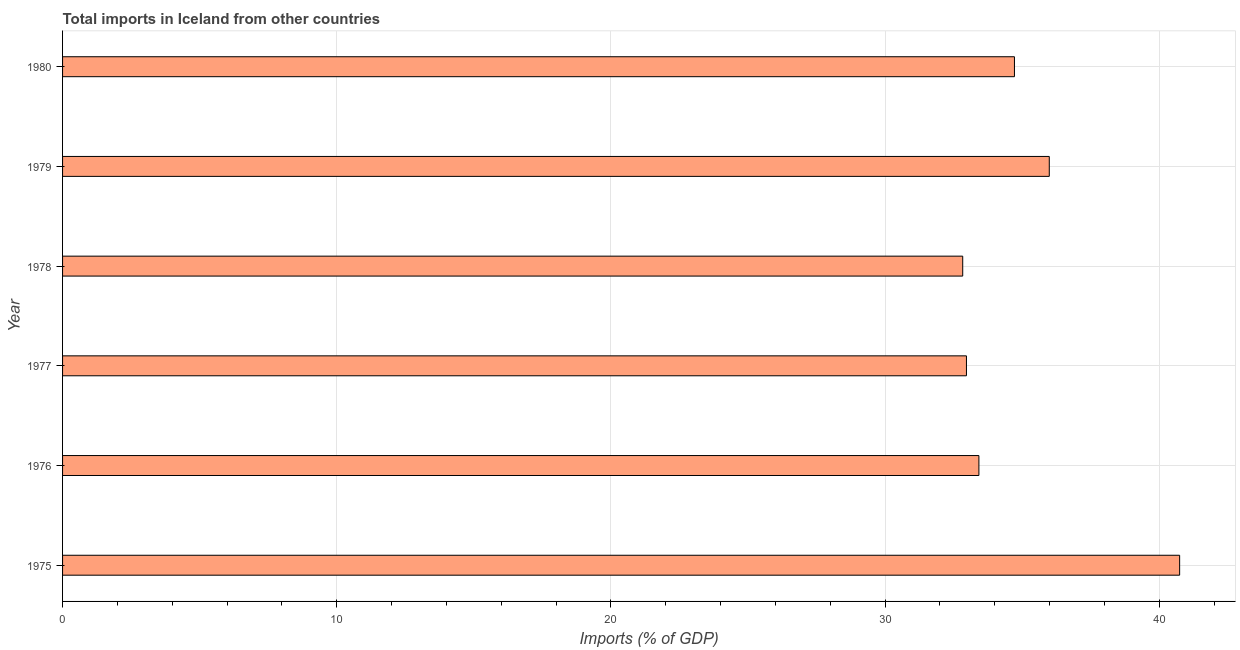Does the graph contain grids?
Offer a very short reply. Yes. What is the title of the graph?
Make the answer very short. Total imports in Iceland from other countries. What is the label or title of the X-axis?
Your answer should be compact. Imports (% of GDP). What is the label or title of the Y-axis?
Provide a short and direct response. Year. What is the total imports in 1980?
Keep it short and to the point. 34.72. Across all years, what is the maximum total imports?
Provide a succinct answer. 40.75. Across all years, what is the minimum total imports?
Provide a short and direct response. 32.83. In which year was the total imports maximum?
Make the answer very short. 1975. In which year was the total imports minimum?
Make the answer very short. 1978. What is the sum of the total imports?
Ensure brevity in your answer.  210.69. What is the difference between the total imports in 1979 and 1980?
Your answer should be very brief. 1.27. What is the average total imports per year?
Provide a short and direct response. 35.11. What is the median total imports?
Your response must be concise. 34.07. What is the difference between the highest and the second highest total imports?
Your answer should be compact. 4.75. What is the difference between the highest and the lowest total imports?
Your response must be concise. 7.91. How many years are there in the graph?
Keep it short and to the point. 6. What is the difference between two consecutive major ticks on the X-axis?
Your answer should be compact. 10. Are the values on the major ticks of X-axis written in scientific E-notation?
Offer a terse response. No. What is the Imports (% of GDP) of 1975?
Your answer should be very brief. 40.75. What is the Imports (% of GDP) in 1976?
Your answer should be compact. 33.42. What is the Imports (% of GDP) of 1977?
Offer a very short reply. 32.97. What is the Imports (% of GDP) of 1978?
Keep it short and to the point. 32.83. What is the Imports (% of GDP) in 1979?
Ensure brevity in your answer.  35.99. What is the Imports (% of GDP) in 1980?
Your answer should be very brief. 34.72. What is the difference between the Imports (% of GDP) in 1975 and 1976?
Your answer should be compact. 7.32. What is the difference between the Imports (% of GDP) in 1975 and 1977?
Make the answer very short. 7.78. What is the difference between the Imports (% of GDP) in 1975 and 1978?
Give a very brief answer. 7.91. What is the difference between the Imports (% of GDP) in 1975 and 1979?
Ensure brevity in your answer.  4.76. What is the difference between the Imports (% of GDP) in 1975 and 1980?
Provide a short and direct response. 6.03. What is the difference between the Imports (% of GDP) in 1976 and 1977?
Your answer should be compact. 0.45. What is the difference between the Imports (% of GDP) in 1976 and 1978?
Keep it short and to the point. 0.59. What is the difference between the Imports (% of GDP) in 1976 and 1979?
Provide a succinct answer. -2.57. What is the difference between the Imports (% of GDP) in 1976 and 1980?
Your answer should be very brief. -1.3. What is the difference between the Imports (% of GDP) in 1977 and 1978?
Your answer should be compact. 0.14. What is the difference between the Imports (% of GDP) in 1977 and 1979?
Offer a very short reply. -3.02. What is the difference between the Imports (% of GDP) in 1977 and 1980?
Your answer should be very brief. -1.75. What is the difference between the Imports (% of GDP) in 1978 and 1979?
Ensure brevity in your answer.  -3.16. What is the difference between the Imports (% of GDP) in 1978 and 1980?
Your answer should be compact. -1.89. What is the difference between the Imports (% of GDP) in 1979 and 1980?
Ensure brevity in your answer.  1.27. What is the ratio of the Imports (% of GDP) in 1975 to that in 1976?
Make the answer very short. 1.22. What is the ratio of the Imports (% of GDP) in 1975 to that in 1977?
Offer a very short reply. 1.24. What is the ratio of the Imports (% of GDP) in 1975 to that in 1978?
Make the answer very short. 1.24. What is the ratio of the Imports (% of GDP) in 1975 to that in 1979?
Provide a succinct answer. 1.13. What is the ratio of the Imports (% of GDP) in 1975 to that in 1980?
Your answer should be compact. 1.17. What is the ratio of the Imports (% of GDP) in 1976 to that in 1977?
Offer a very short reply. 1.01. What is the ratio of the Imports (% of GDP) in 1976 to that in 1978?
Your answer should be compact. 1.02. What is the ratio of the Imports (% of GDP) in 1976 to that in 1979?
Your response must be concise. 0.93. What is the ratio of the Imports (% of GDP) in 1977 to that in 1978?
Your response must be concise. 1. What is the ratio of the Imports (% of GDP) in 1977 to that in 1979?
Give a very brief answer. 0.92. What is the ratio of the Imports (% of GDP) in 1978 to that in 1979?
Your response must be concise. 0.91. What is the ratio of the Imports (% of GDP) in 1978 to that in 1980?
Offer a very short reply. 0.95. 